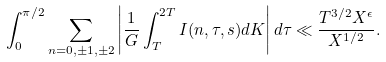Convert formula to latex. <formula><loc_0><loc_0><loc_500><loc_500>\int _ { 0 } ^ { \pi / 2 } \sum _ { n = 0 , \pm 1 , \pm 2 } \left | \frac { 1 } { G } \int _ { T } ^ { 2 T } I ( n , \tau , s ) d K \right | d \tau \ll \frac { T ^ { 3 / 2 } X ^ { \epsilon } } { X ^ { 1 / 2 } } .</formula> 